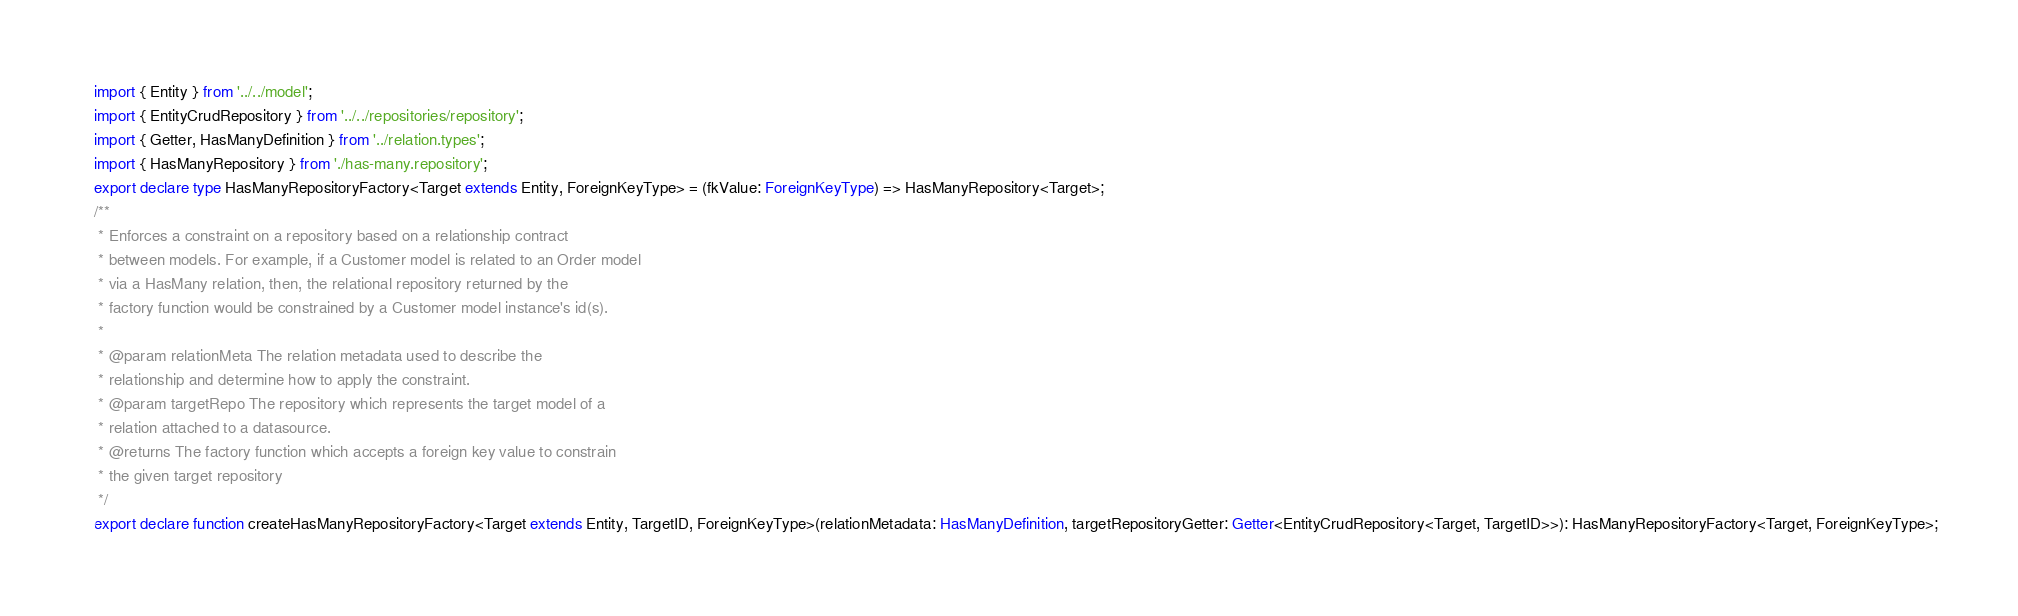Convert code to text. <code><loc_0><loc_0><loc_500><loc_500><_TypeScript_>import { Entity } from '../../model';
import { EntityCrudRepository } from '../../repositories/repository';
import { Getter, HasManyDefinition } from '../relation.types';
import { HasManyRepository } from './has-many.repository';
export declare type HasManyRepositoryFactory<Target extends Entity, ForeignKeyType> = (fkValue: ForeignKeyType) => HasManyRepository<Target>;
/**
 * Enforces a constraint on a repository based on a relationship contract
 * between models. For example, if a Customer model is related to an Order model
 * via a HasMany relation, then, the relational repository returned by the
 * factory function would be constrained by a Customer model instance's id(s).
 *
 * @param relationMeta The relation metadata used to describe the
 * relationship and determine how to apply the constraint.
 * @param targetRepo The repository which represents the target model of a
 * relation attached to a datasource.
 * @returns The factory function which accepts a foreign key value to constrain
 * the given target repository
 */
export declare function createHasManyRepositoryFactory<Target extends Entity, TargetID, ForeignKeyType>(relationMetadata: HasManyDefinition, targetRepositoryGetter: Getter<EntityCrudRepository<Target, TargetID>>): HasManyRepositoryFactory<Target, ForeignKeyType>;
</code> 